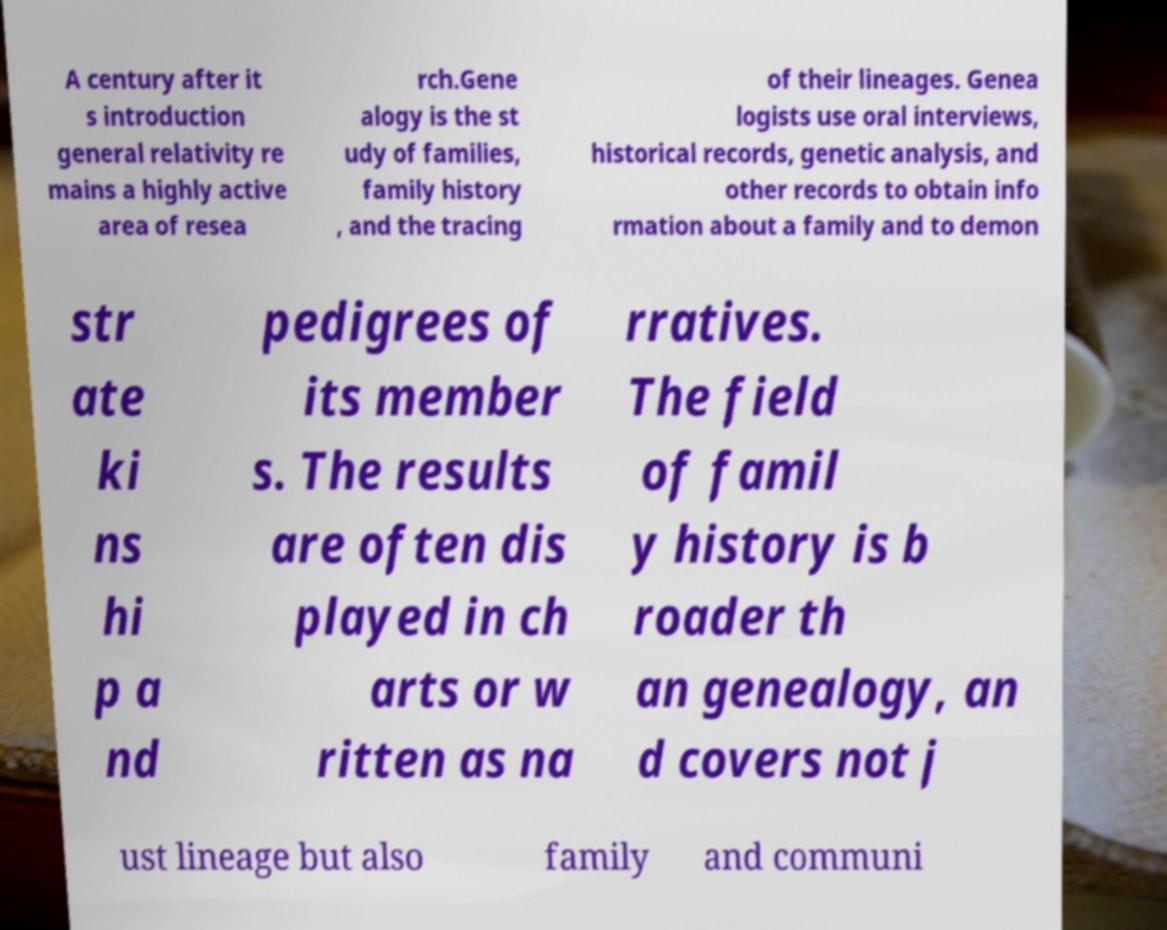Could you extract and type out the text from this image? A century after it s introduction general relativity re mains a highly active area of resea rch.Gene alogy is the st udy of families, family history , and the tracing of their lineages. Genea logists use oral interviews, historical records, genetic analysis, and other records to obtain info rmation about a family and to demon str ate ki ns hi p a nd pedigrees of its member s. The results are often dis played in ch arts or w ritten as na rratives. The field of famil y history is b roader th an genealogy, an d covers not j ust lineage but also family and communi 